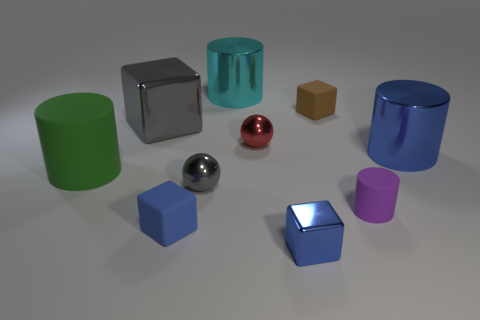What number of cylinders are left of the small cylinder and in front of the big blue cylinder?
Provide a short and direct response. 1. What is the shape of the small metallic thing that is to the left of the sphere that is behind the big green rubber cylinder left of the small blue metal thing?
Your answer should be very brief. Sphere. Is there anything else that has the same shape as the tiny blue matte thing?
Provide a short and direct response. Yes. How many blocks are tiny cyan metallic things or small rubber objects?
Offer a very short reply. 2. Does the big thing to the right of the purple thing have the same color as the small metallic block?
Make the answer very short. Yes. The big thing that is behind the small cube that is behind the big cylinder that is on the right side of the big cyan metallic object is made of what material?
Offer a very short reply. Metal. Is the purple matte thing the same size as the red metal ball?
Make the answer very short. Yes. There is a big cube; is its color the same as the tiny sphere in front of the big blue metal cylinder?
Your answer should be compact. Yes. There is a small blue object that is the same material as the purple cylinder; what is its shape?
Offer a terse response. Cube. There is a blue object to the left of the red metallic thing; does it have the same shape as the cyan object?
Offer a very short reply. No. 